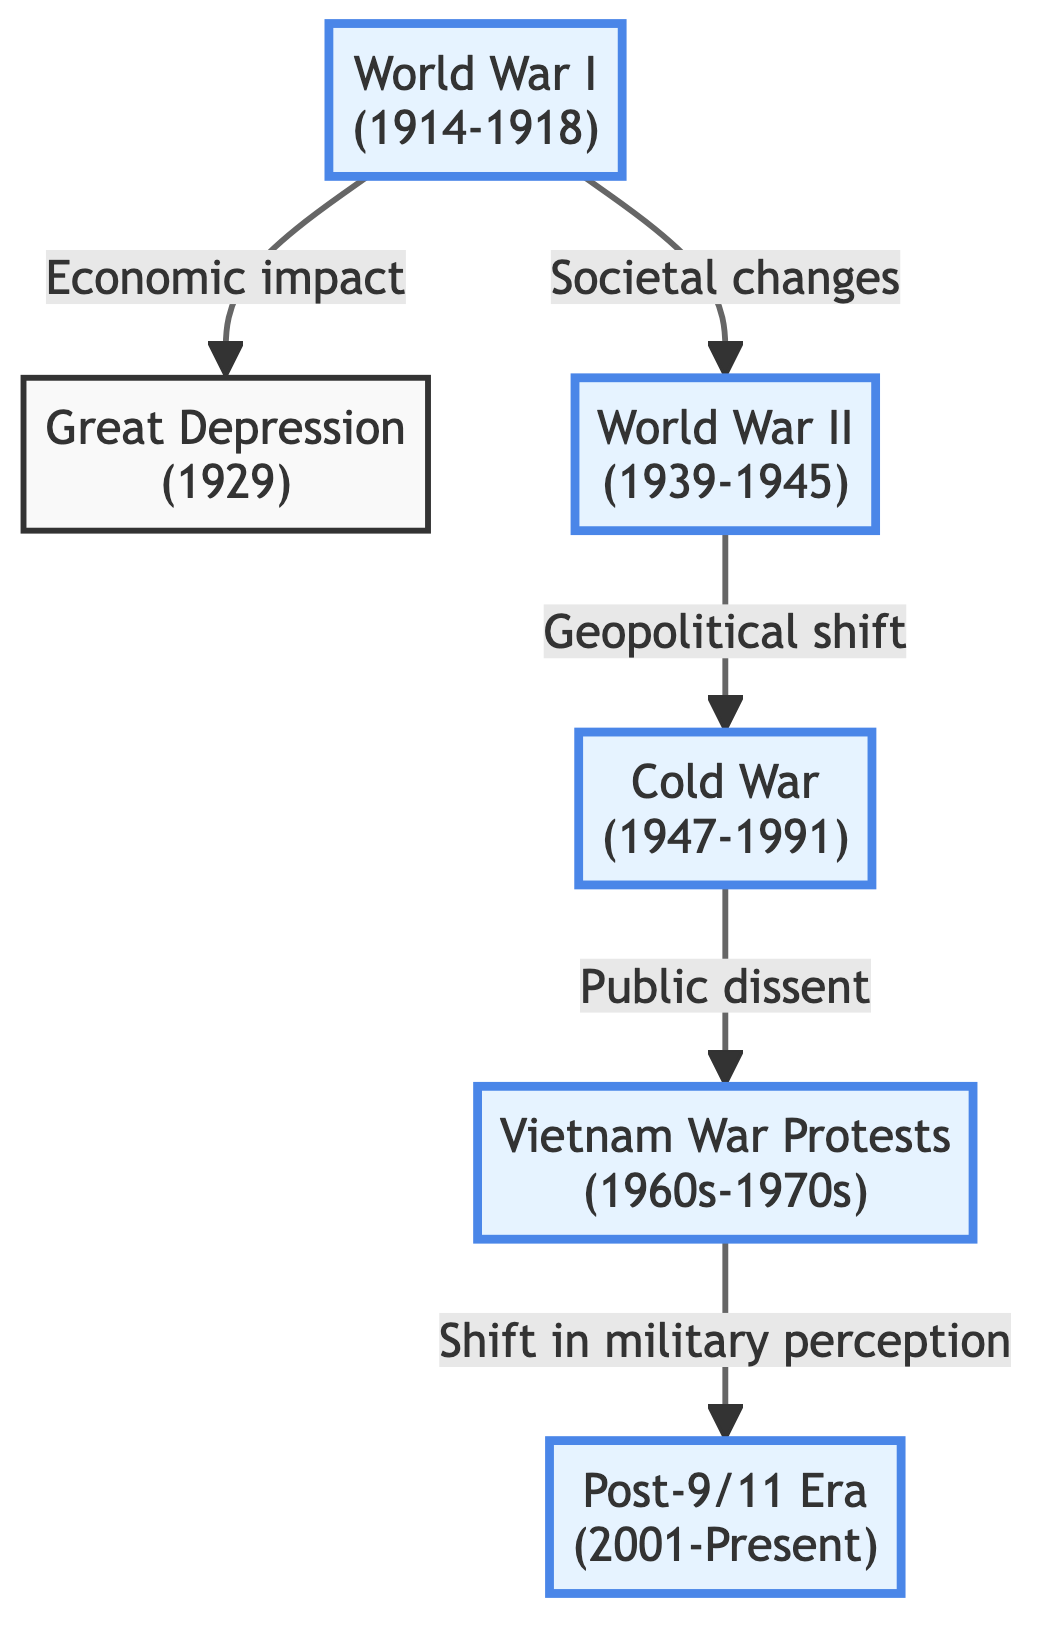What event directly influenced the Great Depression? The arrow shows a direct connection from "World War I" to "Great Depression", indicating it had an economic impact that led to the Great Depression.
Answer: World War I How many eras are represented in the diagram? There are six elements labeled with distinct eras shown in the diagram, starting from World War I to the Post-9/11 Era.
Answer: Six Which events are connected by the relationship labeled "Public dissent"? Following the directed edge labeled "Public dissent", it connects "Cold War" and "Vietnam War Protests", indicating this relationship exists between these two events.
Answer: Cold War and Vietnam War Protests What societal change was prompted by World War II? The diagram indicates a direct societal change leading from "World War II" to the "Cold War" reflecting changes due to geopolitical shifts in society after WWII.
Answer: Geopolitical shift Which event followed the Vietnam War Protests? The directed edge from "Vietnam War Protests" to "Post-9/11 Era" signifies that the social changes from the protests led to shifts in military perception that impacts the Post-9/11 Era.
Answer: Post-9/11 Era What type of war influenced women's entry into the workforce? The label associated with "World War II" and the description indicates significant mobilization of societies, particularly affecting women's roles in the workforce during this time.
Answer: World War II 